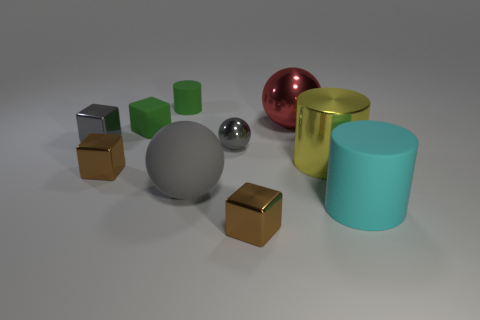Subtract all small rubber cubes. How many cubes are left? 3 Subtract all red balls. How many balls are left? 2 Subtract 3 cylinders. How many cylinders are left? 0 Add 6 yellow metal objects. How many yellow metal objects exist? 7 Subtract 0 brown cylinders. How many objects are left? 10 Subtract all spheres. How many objects are left? 7 Subtract all blue cubes. Subtract all blue cylinders. How many cubes are left? 4 Subtract all yellow cubes. How many gray spheres are left? 2 Subtract all gray blocks. Subtract all large green matte objects. How many objects are left? 9 Add 7 red metallic things. How many red metallic things are left? 8 